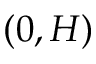<formula> <loc_0><loc_0><loc_500><loc_500>( 0 , H )</formula> 